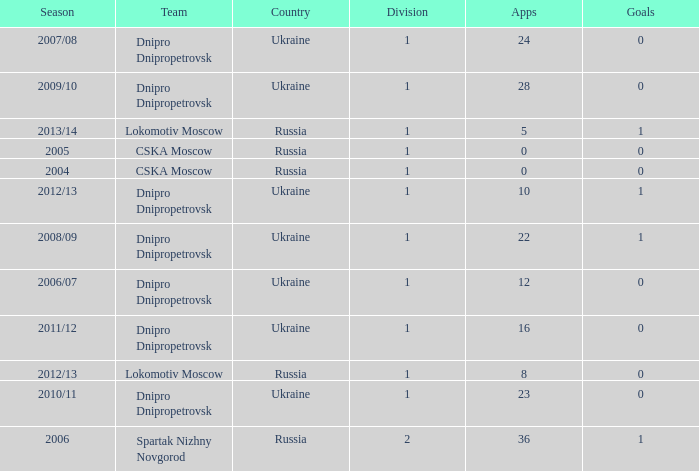What division was Ukraine in 2006/07? 1.0. 